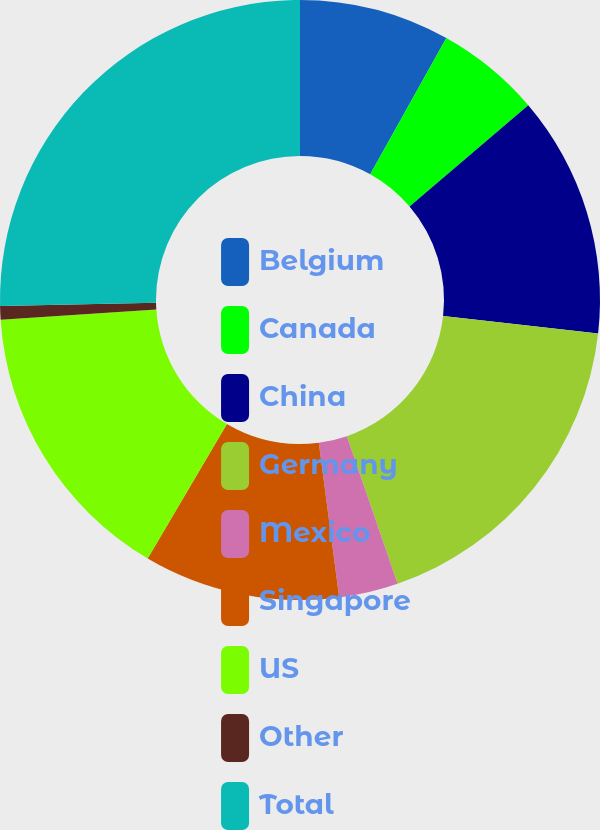Convert chart to OTSL. <chart><loc_0><loc_0><loc_500><loc_500><pie_chart><fcel>Belgium<fcel>Canada<fcel>China<fcel>Germany<fcel>Mexico<fcel>Singapore<fcel>US<fcel>Other<fcel>Total<nl><fcel>8.11%<fcel>5.65%<fcel>13.02%<fcel>17.94%<fcel>3.19%<fcel>10.56%<fcel>15.48%<fcel>0.73%<fcel>25.31%<nl></chart> 